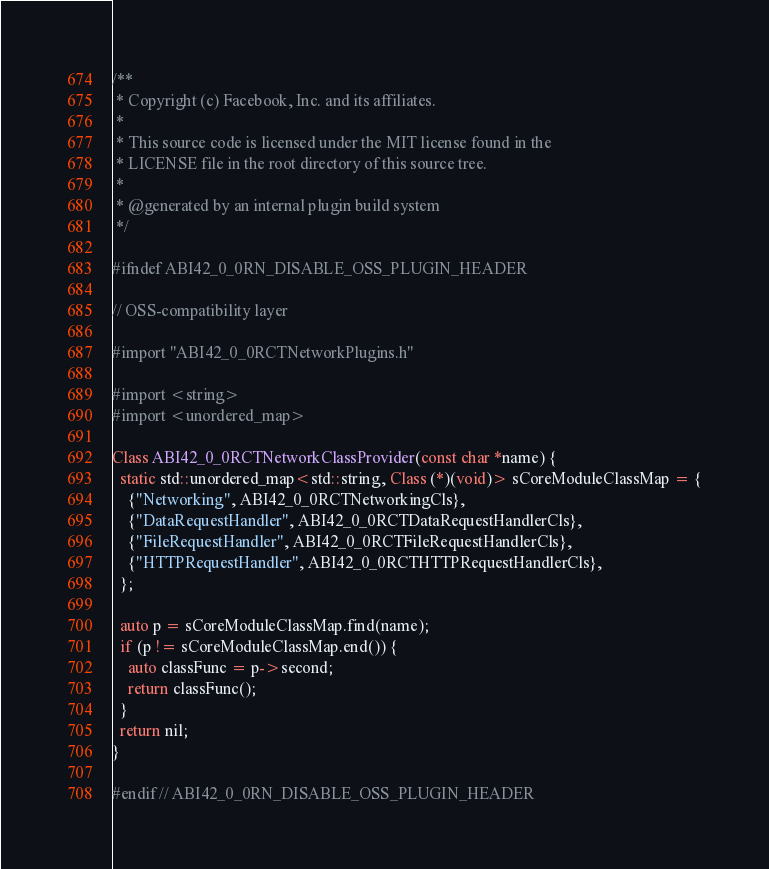<code> <loc_0><loc_0><loc_500><loc_500><_ObjectiveC_>/**
 * Copyright (c) Facebook, Inc. and its affiliates.
 *
 * This source code is licensed under the MIT license found in the
 * LICENSE file in the root directory of this source tree.
 *
 * @generated by an internal plugin build system
 */

#ifndef ABI42_0_0RN_DISABLE_OSS_PLUGIN_HEADER

// OSS-compatibility layer

#import "ABI42_0_0RCTNetworkPlugins.h"

#import <string>
#import <unordered_map>

Class ABI42_0_0RCTNetworkClassProvider(const char *name) {
  static std::unordered_map<std::string, Class (*)(void)> sCoreModuleClassMap = {
    {"Networking", ABI42_0_0RCTNetworkingCls},
    {"DataRequestHandler", ABI42_0_0RCTDataRequestHandlerCls},
    {"FileRequestHandler", ABI42_0_0RCTFileRequestHandlerCls},
    {"HTTPRequestHandler", ABI42_0_0RCTHTTPRequestHandlerCls},
  };

  auto p = sCoreModuleClassMap.find(name);
  if (p != sCoreModuleClassMap.end()) {
    auto classFunc = p->second;
    return classFunc();
  }
  return nil;
}

#endif // ABI42_0_0RN_DISABLE_OSS_PLUGIN_HEADER
</code> 